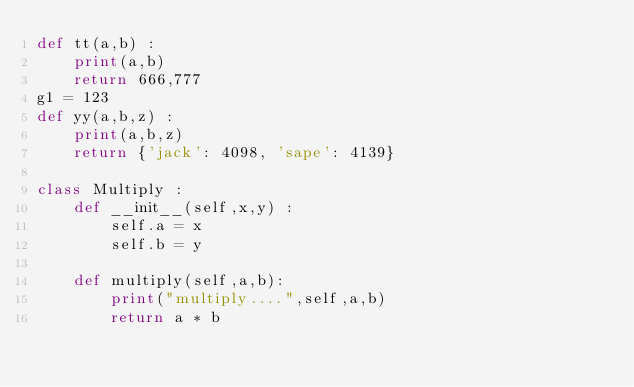Convert code to text. <code><loc_0><loc_0><loc_500><loc_500><_Python_>def tt(a,b) :
    print(a,b)
    return 666,777
g1 = 123
def yy(a,b,z) :
    print(a,b,z)
    return {'jack': 4098, 'sape': 4139}

class Multiply :
    def __init__(self,x,y) :
        self.a = x
        self.b = y

    def multiply(self,a,b):
        print("multiply....",self,a,b)
        return a * b</code> 